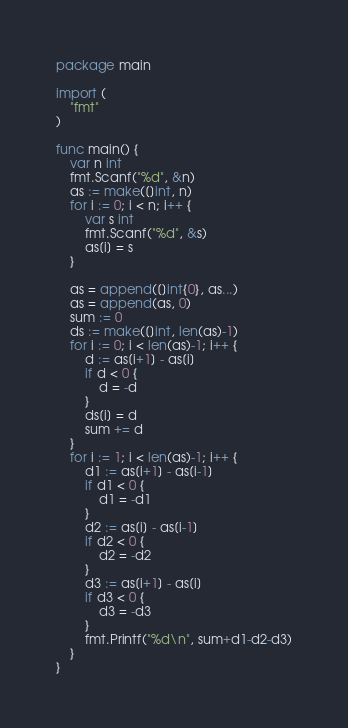<code> <loc_0><loc_0><loc_500><loc_500><_Go_>package main

import (
	"fmt"
)

func main() {
	var n int
	fmt.Scanf("%d", &n)
	as := make([]int, n)
	for i := 0; i < n; i++ {
		var s int
		fmt.Scanf("%d", &s)
		as[i] = s
	}

	as = append([]int{0}, as...)
	as = append(as, 0)
	sum := 0
	ds := make([]int, len(as)-1)
	for i := 0; i < len(as)-1; i++ {
		d := as[i+1] - as[i]
		if d < 0 {
			d = -d
		}
		ds[i] = d
		sum += d
	}
	for i := 1; i < len(as)-1; i++ {
		d1 := as[i+1] - as[i-1]
		if d1 < 0 {
			d1 = -d1
		}
		d2 := as[i] - as[i-1]
		if d2 < 0 {
			d2 = -d2
		}
		d3 := as[i+1] - as[i]
		if d3 < 0 {
			d3 = -d3
		}
		fmt.Printf("%d\n", sum+d1-d2-d3)
	}
}
</code> 